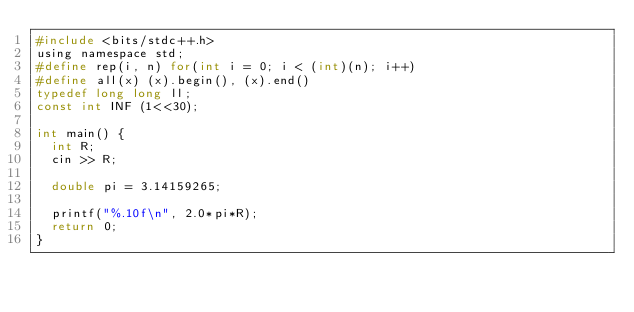Convert code to text. <code><loc_0><loc_0><loc_500><loc_500><_C_>#include <bits/stdc++.h>
using namespace std;
#define rep(i, n) for(int i = 0; i < (int)(n); i++)
#define all(x) (x).begin(), (x).end()
typedef long long ll;
const int INF (1<<30);

int main() {
  int R;
  cin >> R;

  double pi = 3.14159265;

  printf("%.10f\n", 2.0*pi*R);
  return 0;
}
</code> 